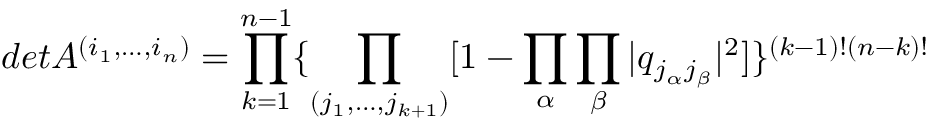Convert formula to latex. <formula><loc_0><loc_0><loc_500><loc_500>d e t A ^ { ( i _ { 1 } , \dots , i _ { n } ) } = \prod _ { k = 1 } ^ { n - 1 } \{ \prod _ { ( j _ { 1 } , \dots , j _ { k + 1 } ) } [ 1 - \prod _ { \alpha } \prod _ { \beta } | q _ { j _ { \alpha } j _ { \beta } } | ^ { 2 } ] \} ^ { ( k - 1 ) ! ( n - k ) ! }</formula> 